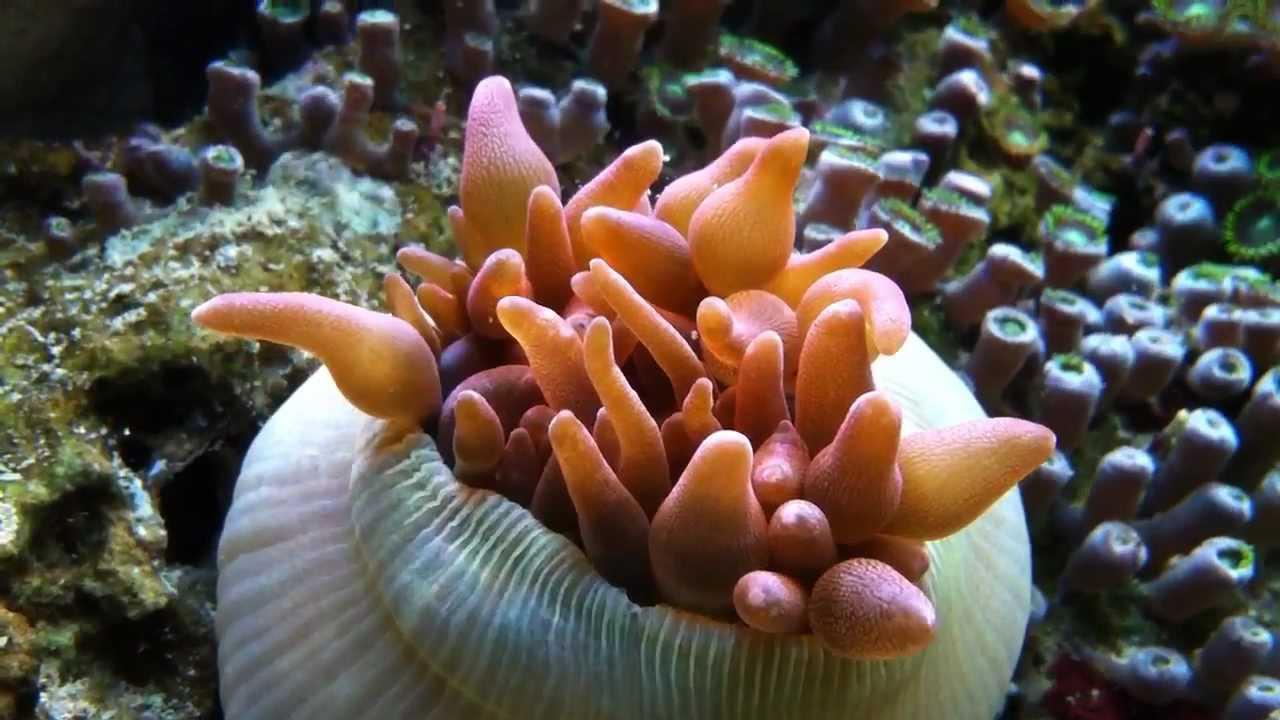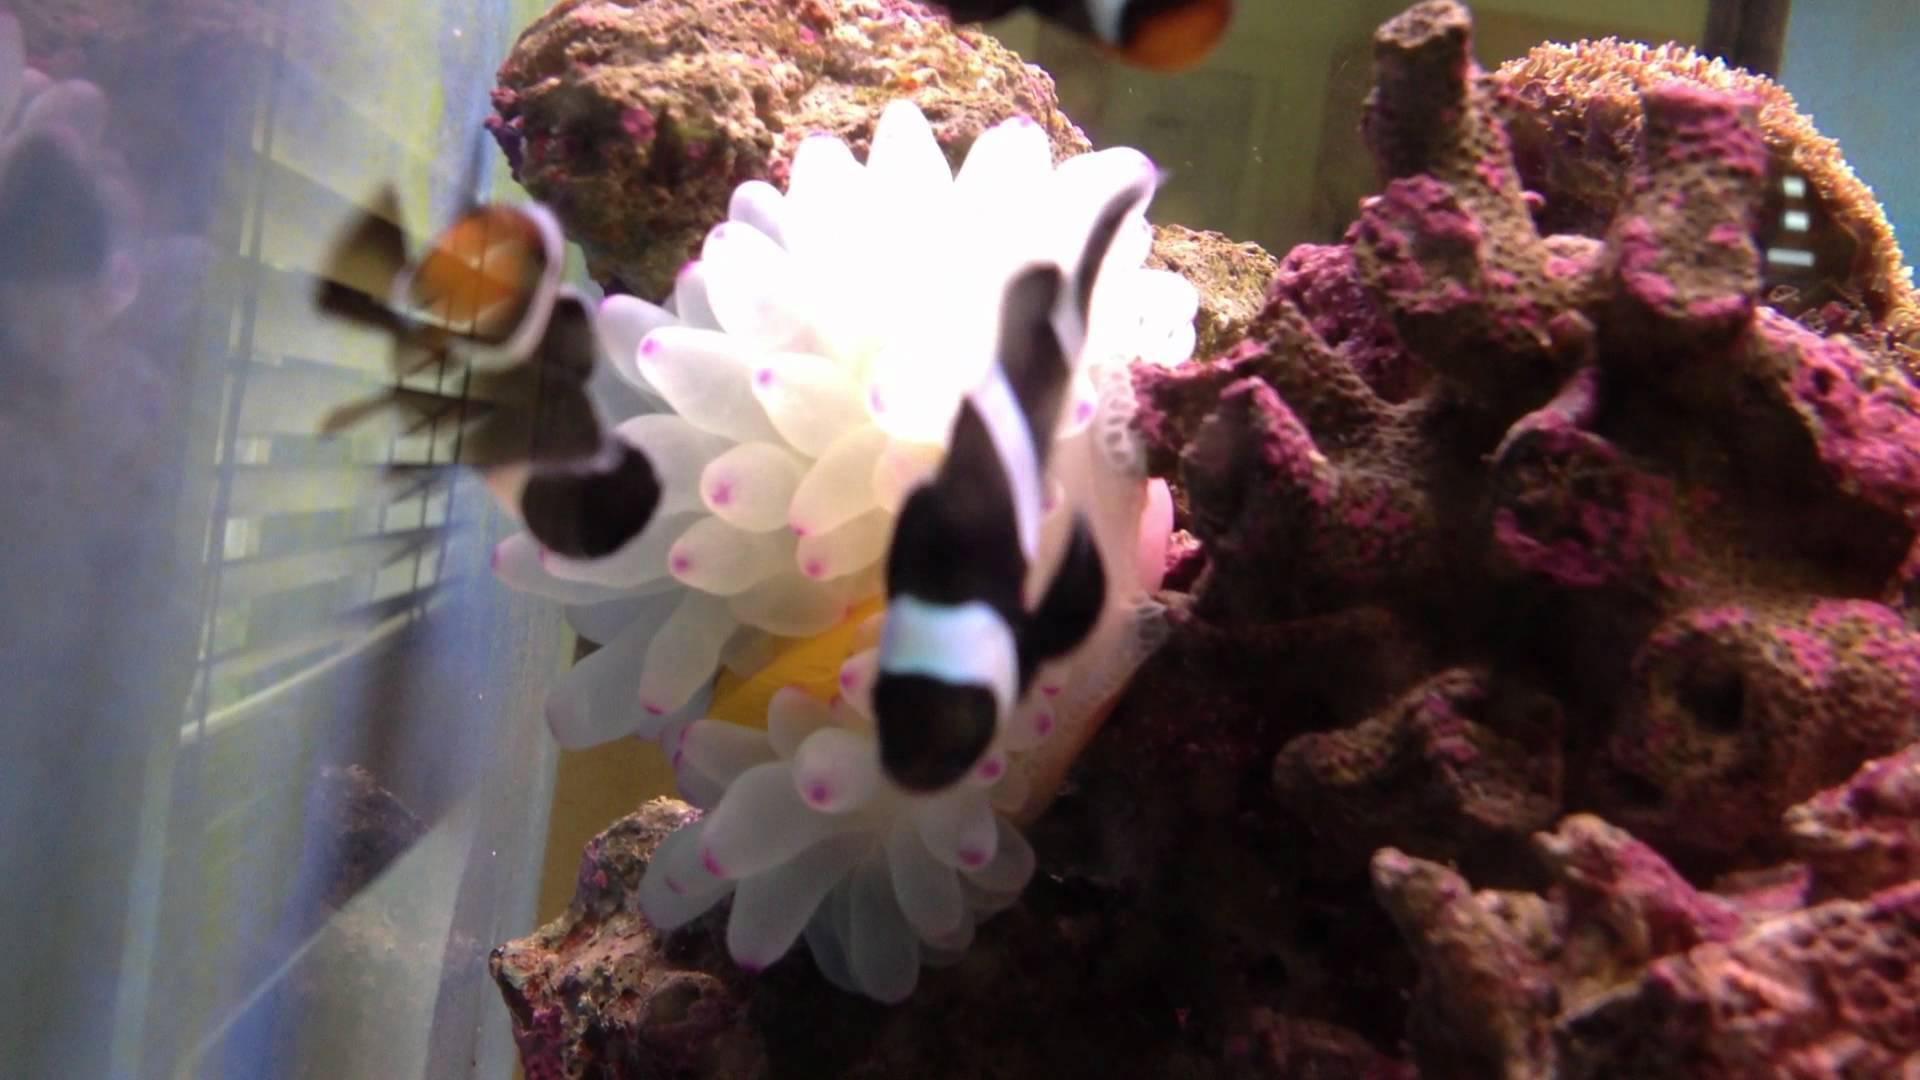The first image is the image on the left, the second image is the image on the right. For the images shown, is this caption "In one image, there is a black and white striped fish visible near a sea anemone" true? Answer yes or no. Yes. The first image is the image on the left, the second image is the image on the right. Given the left and right images, does the statement "The right image shows a pinkish anemone with a fish in its tendrils." hold true? Answer yes or no. No. 